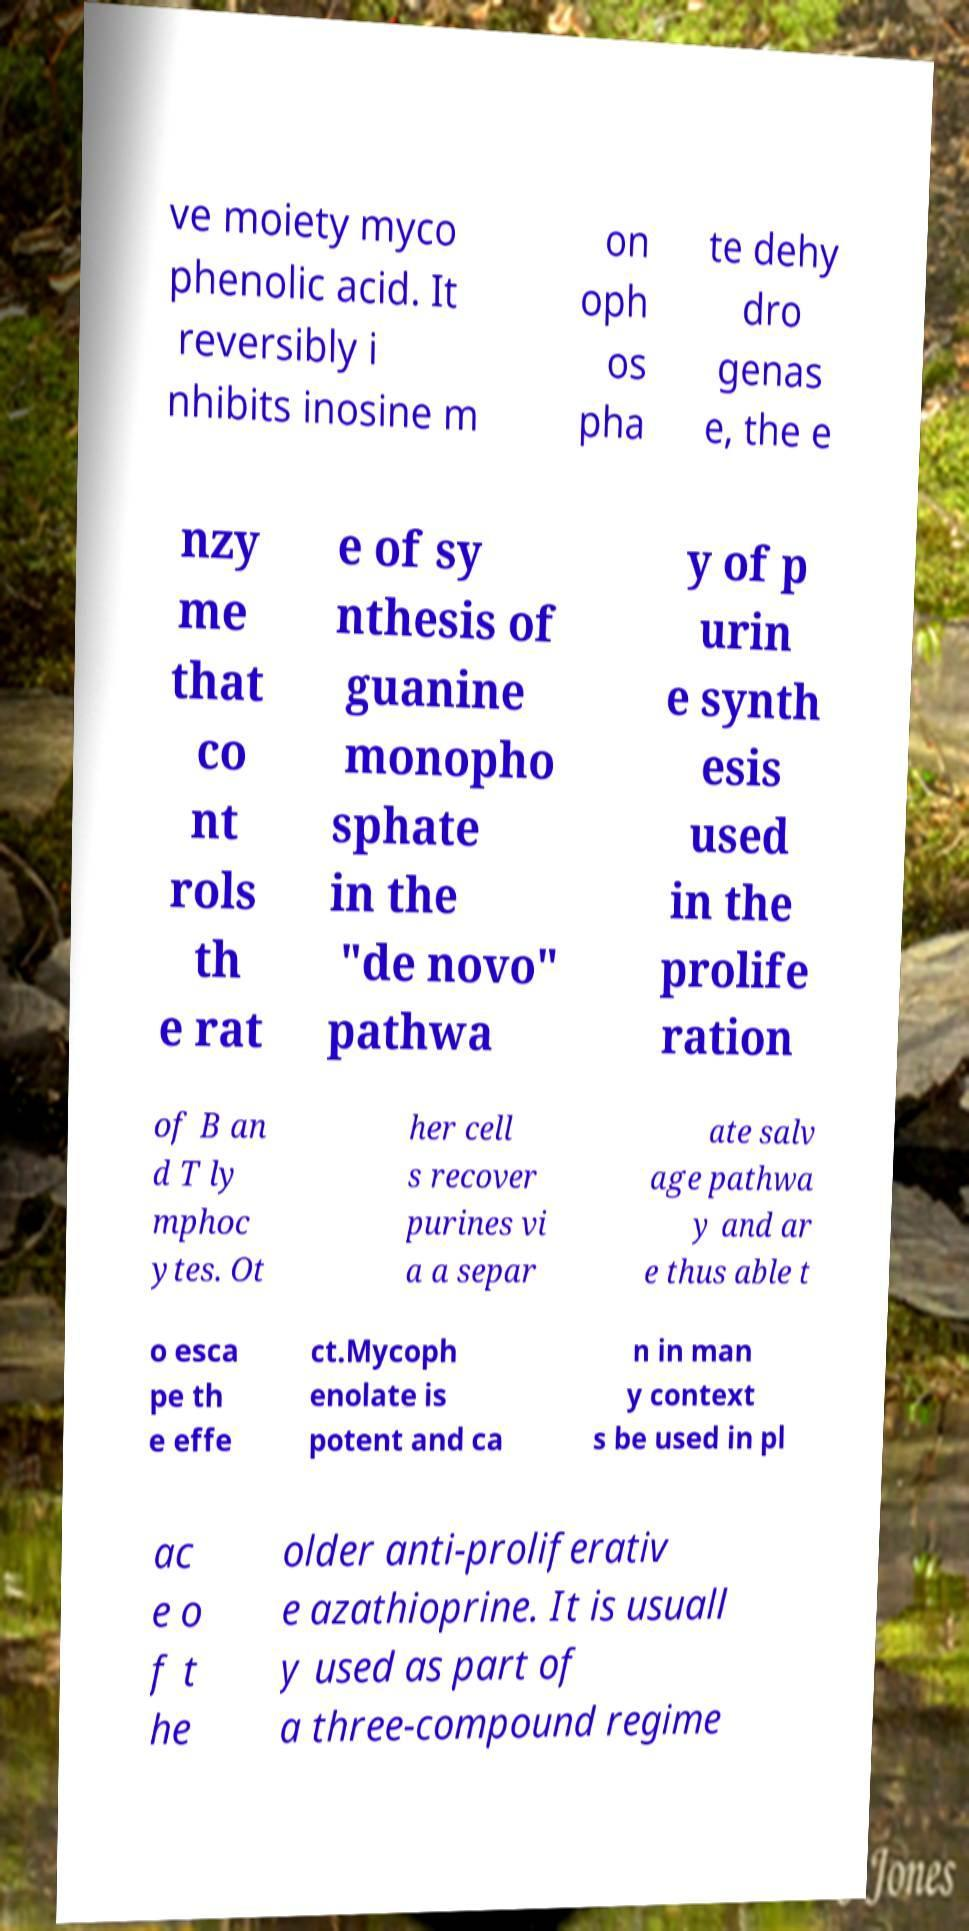Can you read and provide the text displayed in the image?This photo seems to have some interesting text. Can you extract and type it out for me? ve moiety myco phenolic acid. It reversibly i nhibits inosine m on oph os pha te dehy dro genas e, the e nzy me that co nt rols th e rat e of sy nthesis of guanine monopho sphate in the "de novo" pathwa y of p urin e synth esis used in the prolife ration of B an d T ly mphoc ytes. Ot her cell s recover purines vi a a separ ate salv age pathwa y and ar e thus able t o esca pe th e effe ct.Mycoph enolate is potent and ca n in man y context s be used in pl ac e o f t he older anti-proliferativ e azathioprine. It is usuall y used as part of a three-compound regime 